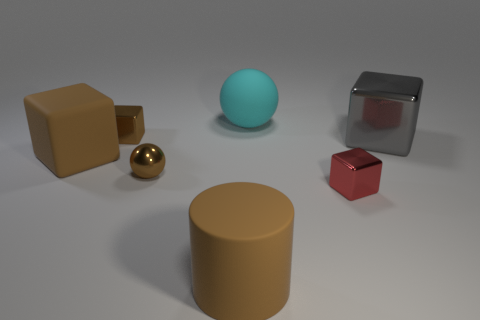There is a tiny thing that is behind the gray cube; does it have the same color as the sphere in front of the large gray object? yes 